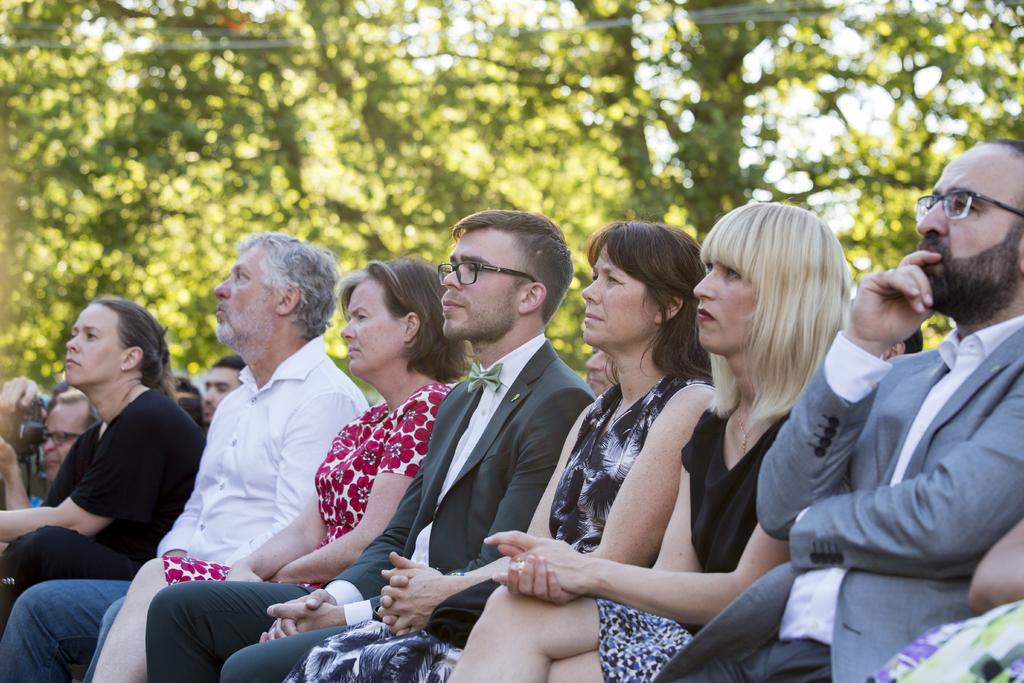What is the general activity of the people in the image? There is a group of people sitting in the image. Can you describe any specific details about one of the people in the group? One person in the group is wearing spectacles. What is the person wearing spectacles holding? The person wearing spectacles is holding a camera. What can be seen in the background of the image? There are trees and wires visible in the background of the image. What type of wood is being used for the discussion in the image? There is no discussion or wood present in the image; it features a group of people sitting, one of whom is wearing spectacles and holding a camera. Can you tell me how many calculators are visible in the image? There are no calculators visible in the image. 